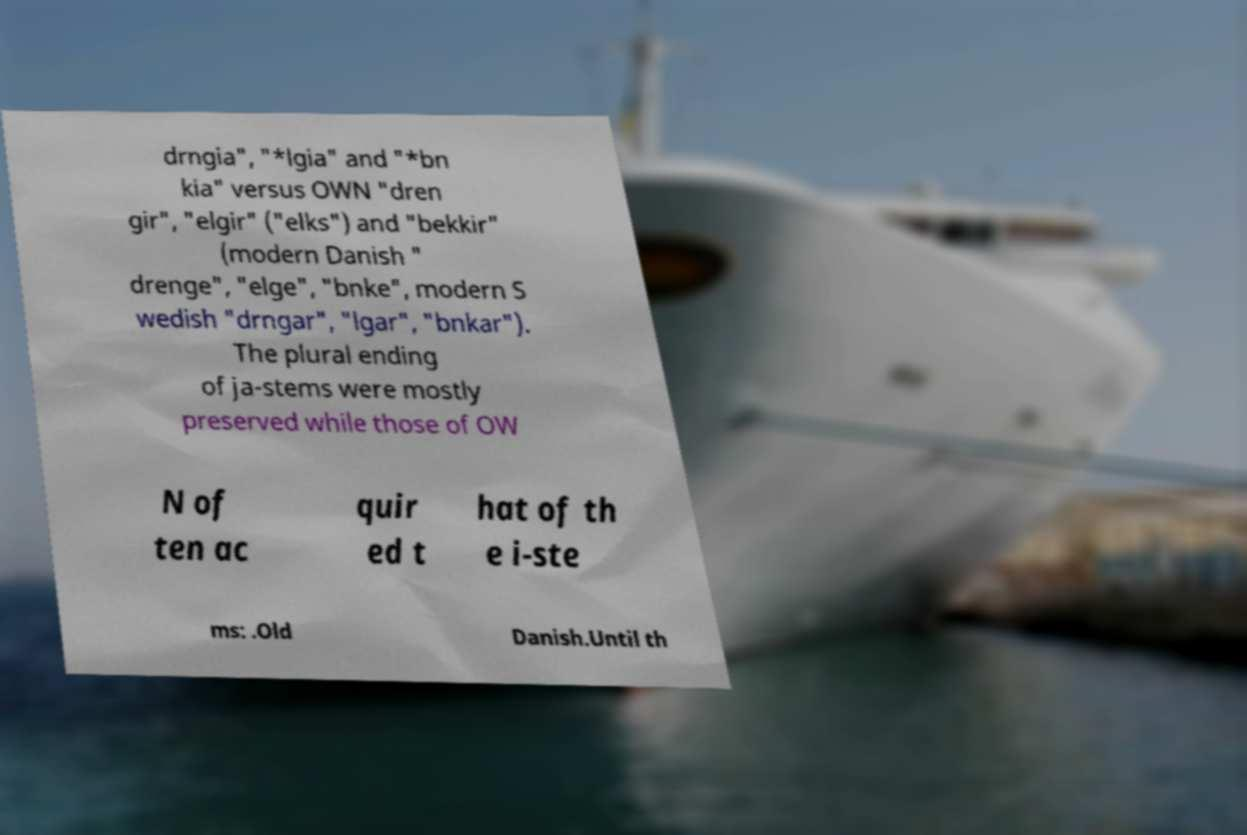Could you extract and type out the text from this image? drngia", "*lgia" and "*bn kia" versus OWN "dren gir", "elgir" ("elks") and "bekkir" (modern Danish " drenge", "elge", "bnke", modern S wedish "drngar", "lgar", "bnkar"). The plural ending of ja-stems were mostly preserved while those of OW N of ten ac quir ed t hat of th e i-ste ms: .Old Danish.Until th 